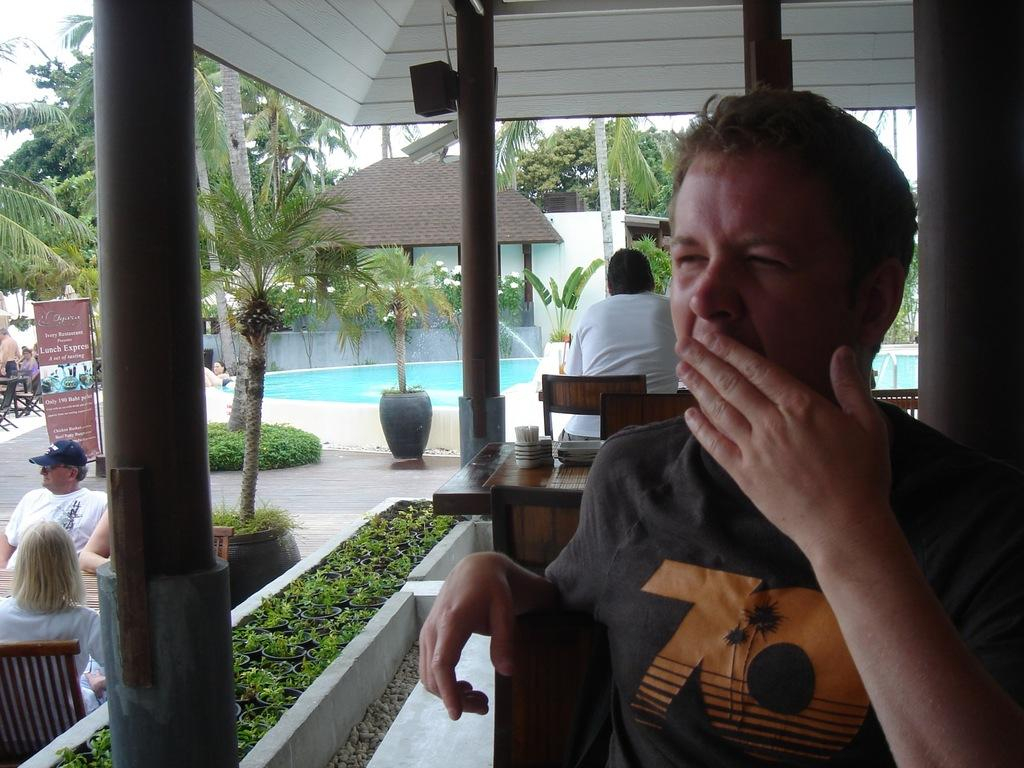What is the man in the image doing? The man is sitting on a chair in the image. Can you describe the people in the background? There are two other persons sitting in the background. What can be seen in the image besides the people? There is a pole, a tree, a building, and water visible in the image. How many frogs are sitting on the man's head in the image? There are no frogs present in the image, so it is not possible to answer that question. 